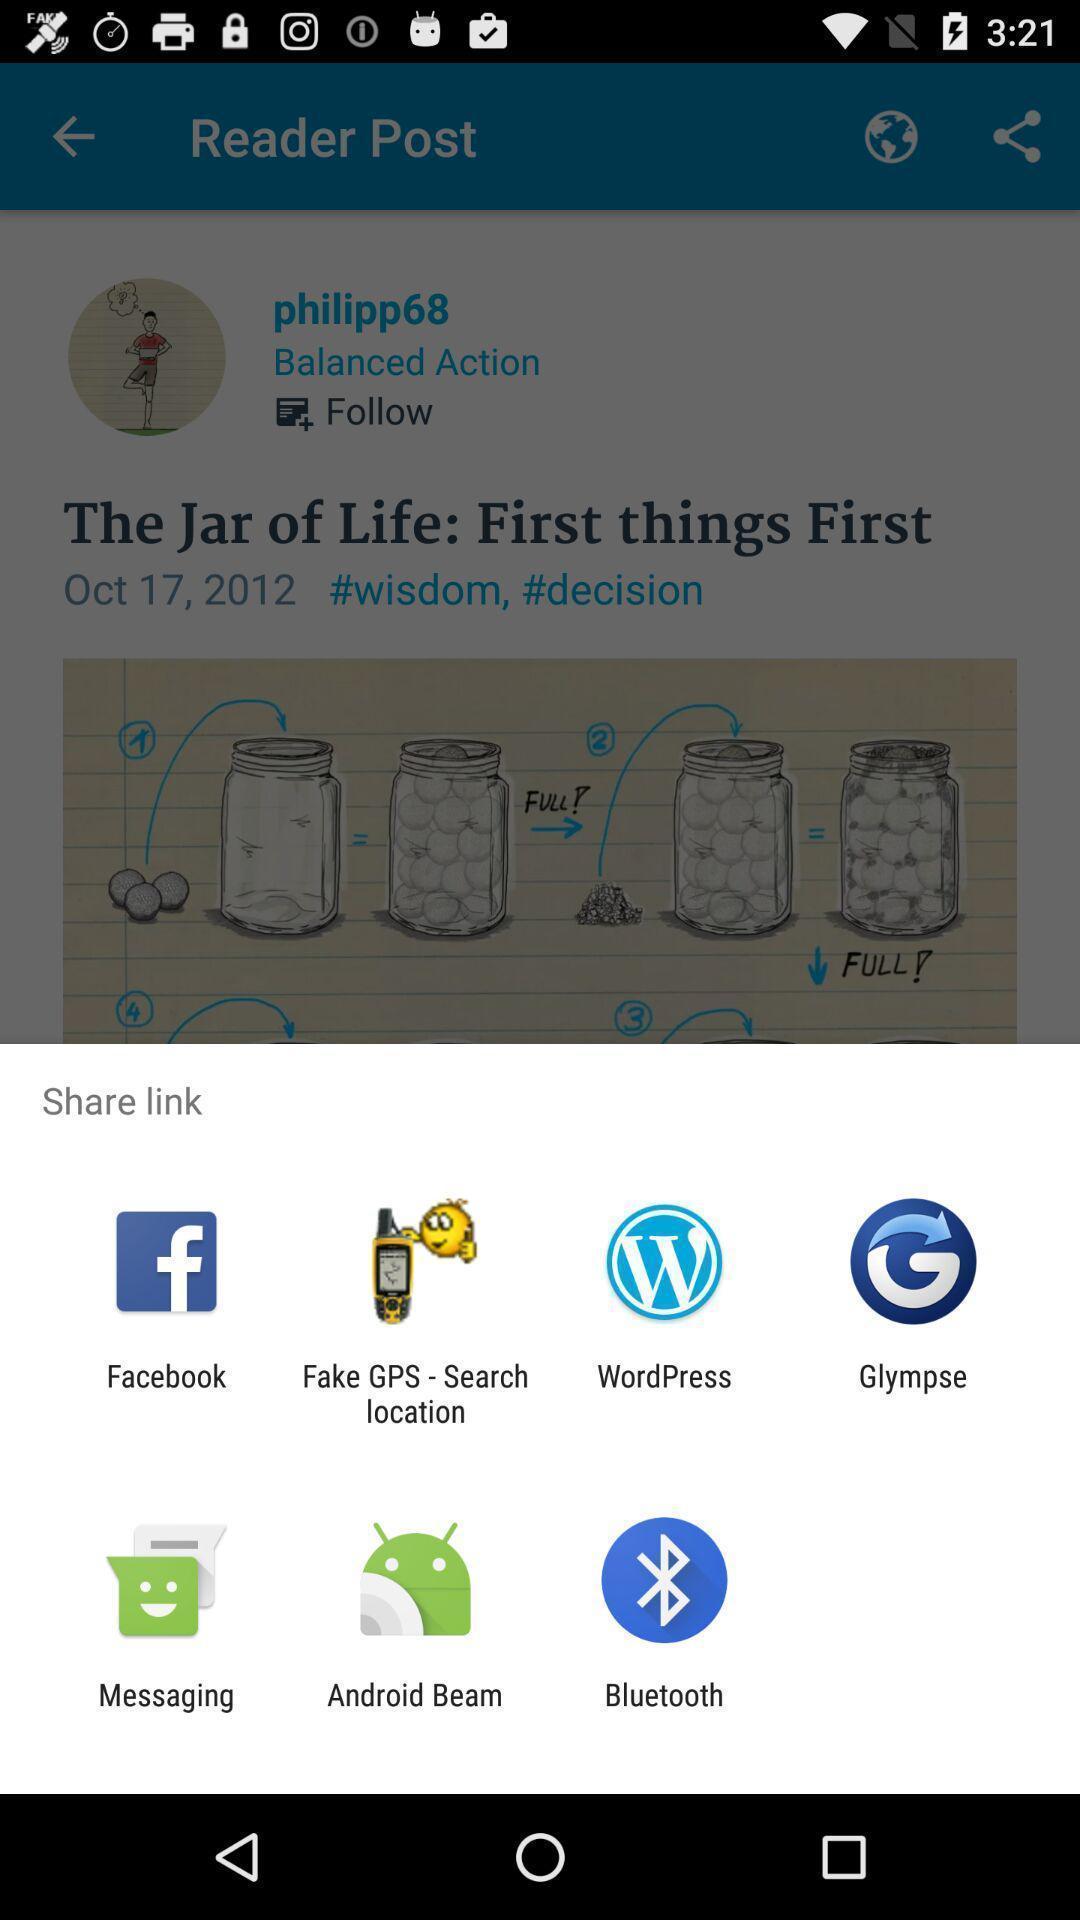Tell me about the visual elements in this screen capture. Popup to share link in the reading app. 